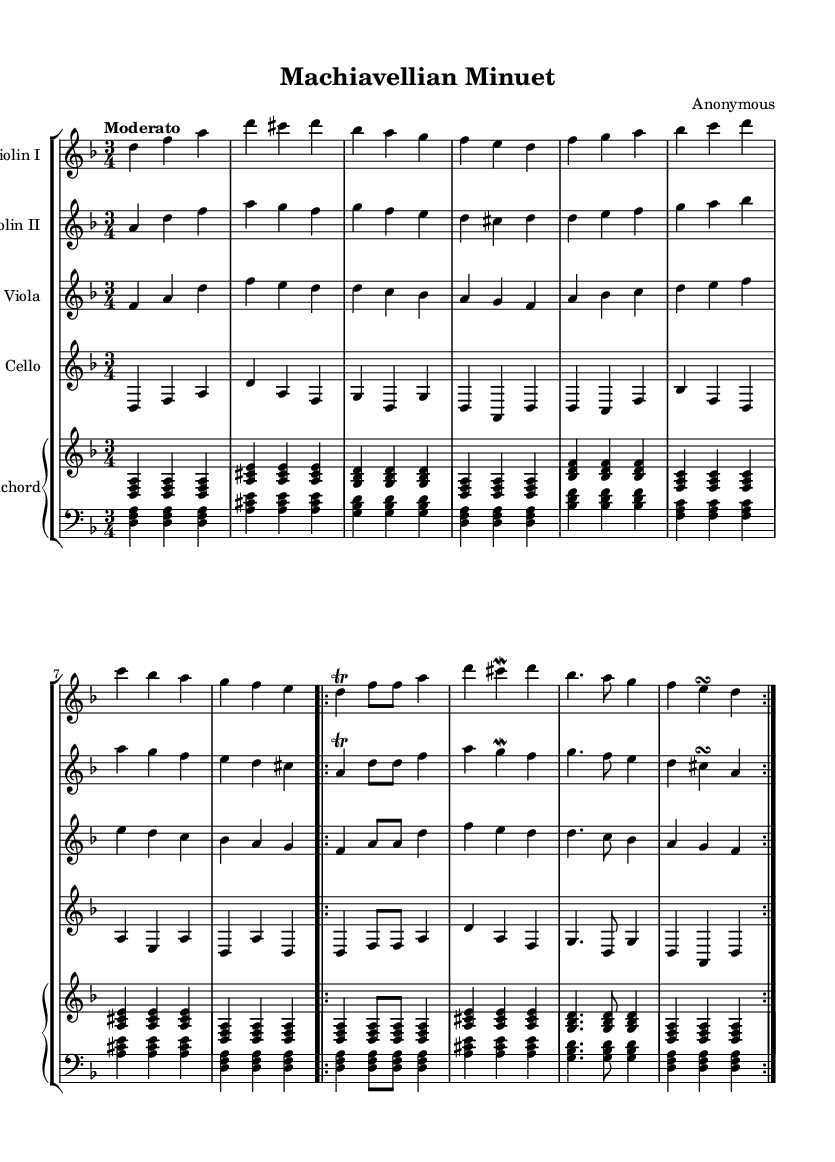What is the key signature of this music? The key signature is indicated at the beginning of the piece, showing two flats which correspond to D minor.
Answer: D minor What is the time signature of this music? The time signature is shown at the beginning of the score, which is 3/4 time, meaning there are three beats in a measure and a quarter note gets one beat.
Answer: 3/4 What is the tempo marking of the piece? The tempo marking "Moderato" is located above the staff and indicates that the piece should be played at a moderate speed.
Answer: Moderato How many voices are in the orchestration? The score contains five distinct parts: Violin I, Violin II, Viola, Cello, and Harpsichord, indicating five voices.
Answer: Five What type of ornamentation is used in this piece? The sheet music indicates various ornamentations such as trills and mordents, which are symbols placed above or below notes that indicate embellishment.
Answer: Trills and mordents What structural pattern is repeated in the piece? The repeat sign and the notation "volta" indicate that the last section of the piece should be played twice, indicating a thematic repetition.
Answer: Volta What is the instrumentation of the piece? The instrumentation is listed at the beginning of each staff, showing that the piece consists of Violin I, Violin II, Viola, Cello, and Harpsichord.
Answer: Strings and harpsichord 